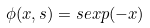<formula> <loc_0><loc_0><loc_500><loc_500>\phi ( x , s ) = s e x p ( - x )</formula> 